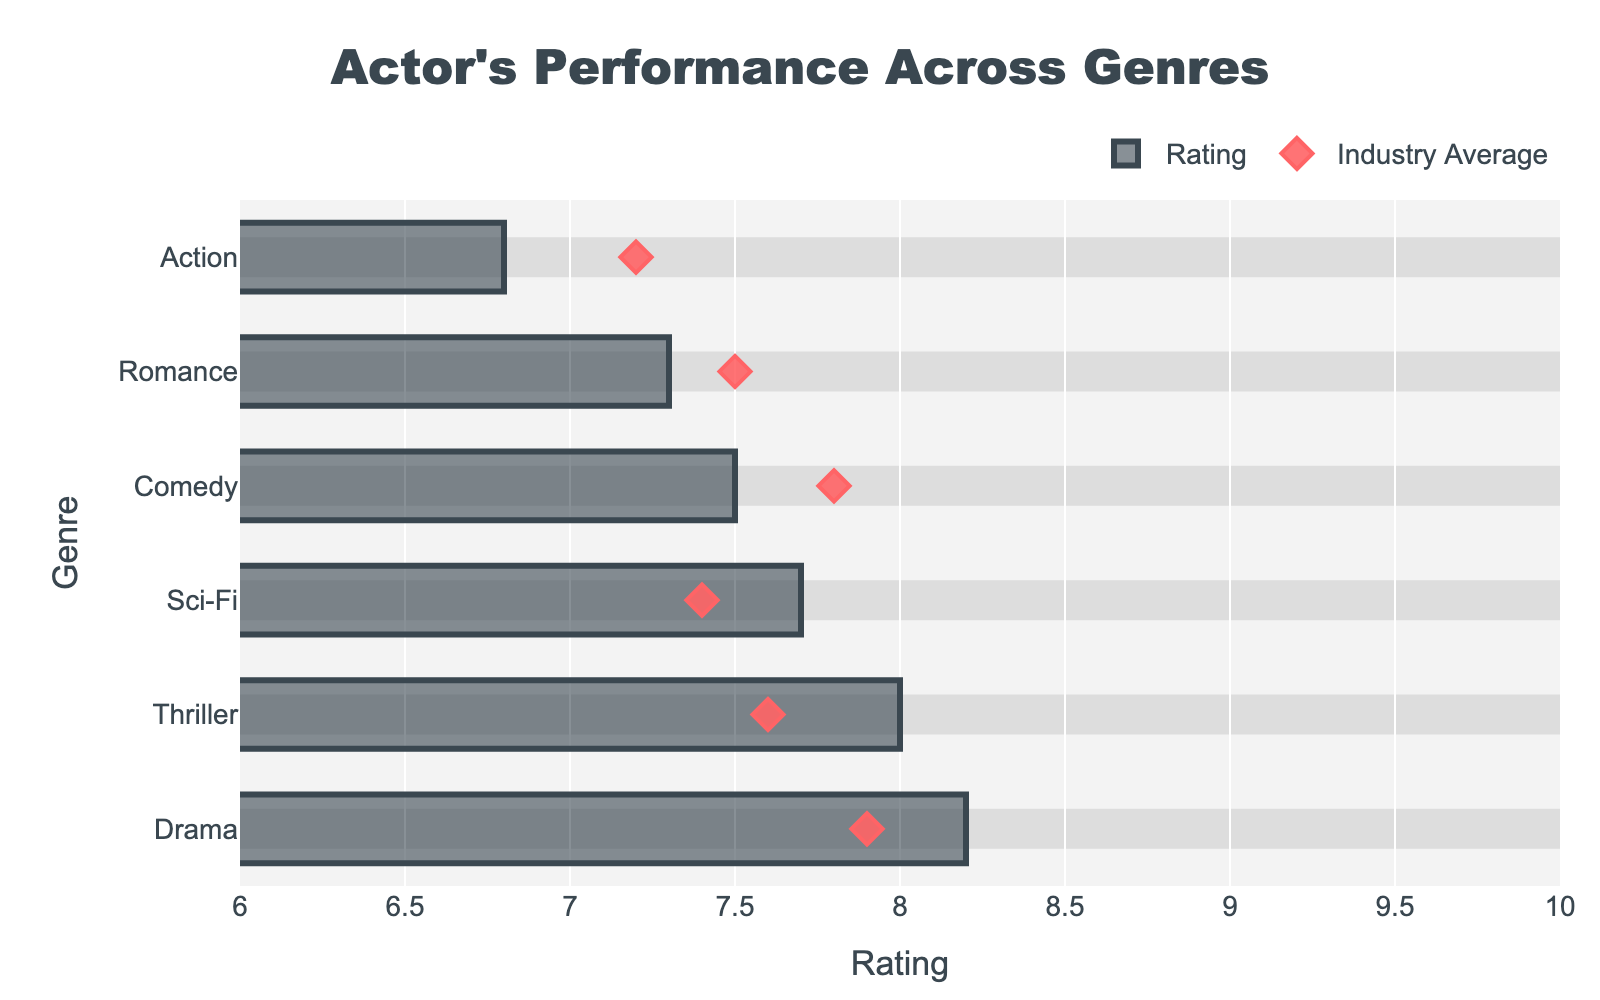What is the title of the figure? The title is displayed at the top center of the figure and usually summarizes the main topic of the chart. In this case, the title is "Actor's Performance Across Genres".
Answer: "Actor's Performance Across Genres" Which genre has the highest audience rating? The highest bar represents the genre with the highest rating. According to the figure, Drama has the highest rating.
Answer: Drama How does the action genre's rating compare to the industry average? Locate the rating bar for Action and compare it to the diamond marker for the industry average. The Action rating is 6.8, and the industry average for Action is 7.2.
Answer: Action rating of 6.8 is lower than the industry average of 7.2 What is the average rating of all genres presented? Sum all ratings and divide by the number of genres. (8.2+7.5+6.8+7.3+8.0+7.7) / 6 = 45.5 / 6 ≈ 7.58
Answer: 7.58 How many genres have ratings higher than their industry average? Compare each genre's rating with its industry average. Drama (8.2 > 7.9), Thriller (8.0 > 7.6), Sci-Fi (7.7 > 7.4). Thus, 3 genres have ratings higher than the industry average.
Answer: 3 genres What is the range of ratings for the genres in the chart? The range is calculated as the difference between the maximum and minimum rating values among the genres. The maximum rating is 8.2 (Drama) and the minimum is 6.8 (Action), so the range is 8.2 - 6.8 = 1.4.
Answer: 1.4 